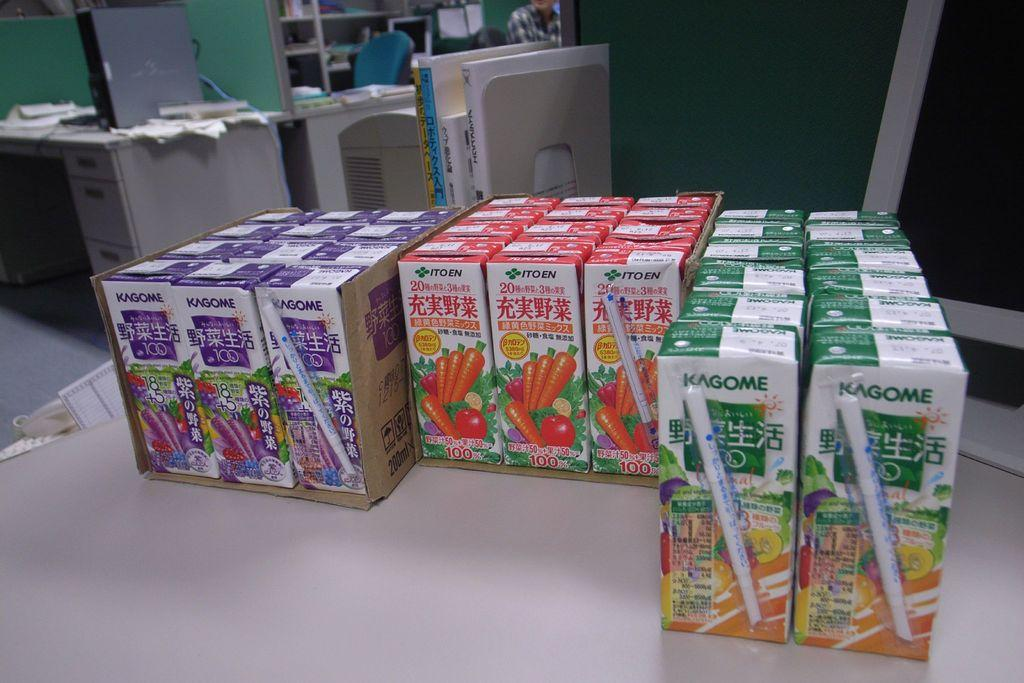Provide a one-sentence caption for the provided image. Kogome juice boxes come in a variety of different flavors and include an attached straw. 